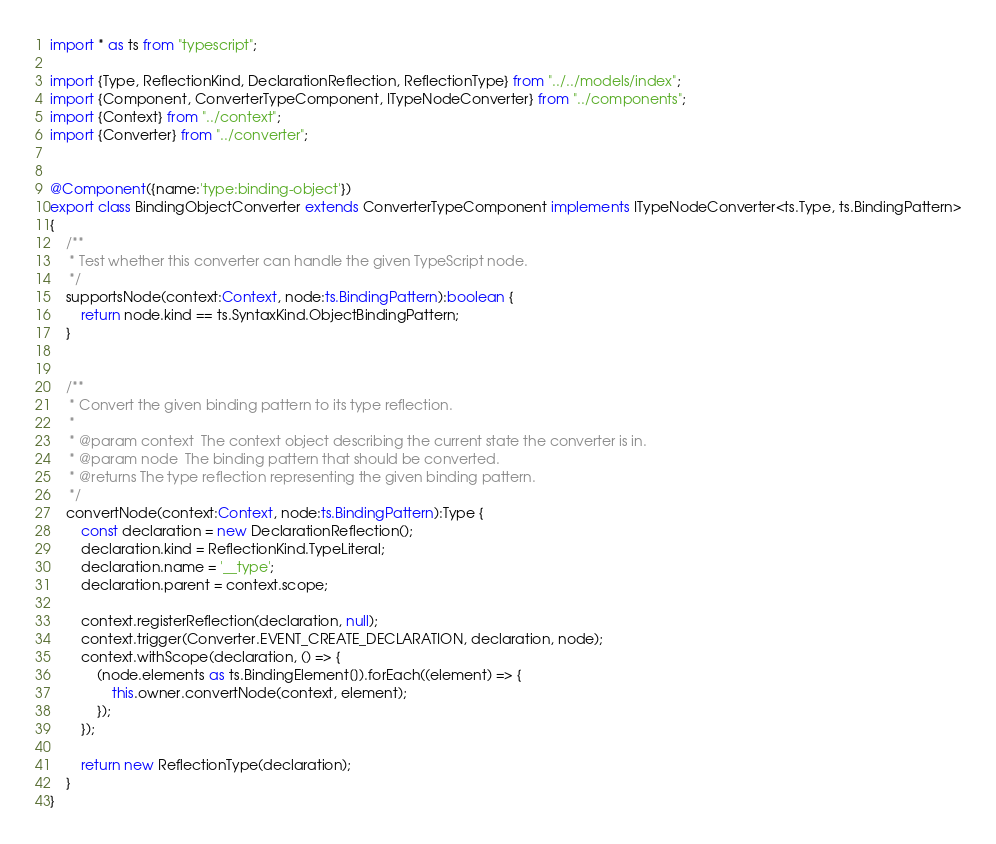<code> <loc_0><loc_0><loc_500><loc_500><_TypeScript_>import * as ts from "typescript";

import {Type, ReflectionKind, DeclarationReflection, ReflectionType} from "../../models/index";
import {Component, ConverterTypeComponent, ITypeNodeConverter} from "../components";
import {Context} from "../context";
import {Converter} from "../converter";


@Component({name:'type:binding-object'})
export class BindingObjectConverter extends ConverterTypeComponent implements ITypeNodeConverter<ts.Type, ts.BindingPattern>
{
    /**
     * Test whether this converter can handle the given TypeScript node.
     */
    supportsNode(context:Context, node:ts.BindingPattern):boolean {
        return node.kind == ts.SyntaxKind.ObjectBindingPattern;
    }


    /**
     * Convert the given binding pattern to its type reflection.
     *
     * @param context  The context object describing the current state the converter is in.
     * @param node  The binding pattern that should be converted.
     * @returns The type reflection representing the given binding pattern.
     */
    convertNode(context:Context, node:ts.BindingPattern):Type {
        const declaration = new DeclarationReflection();
        declaration.kind = ReflectionKind.TypeLiteral;
        declaration.name = '__type';
        declaration.parent = context.scope;

        context.registerReflection(declaration, null);
        context.trigger(Converter.EVENT_CREATE_DECLARATION, declaration, node);
        context.withScope(declaration, () => {
            (node.elements as ts.BindingElement[]).forEach((element) => {
                this.owner.convertNode(context, element);
            });
        });

        return new ReflectionType(declaration);
    }
}
</code> 